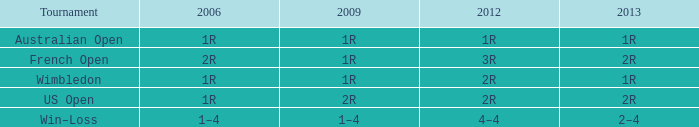What were the shows in 2006 when the ones in 2013 were 2-4? 1–4. 